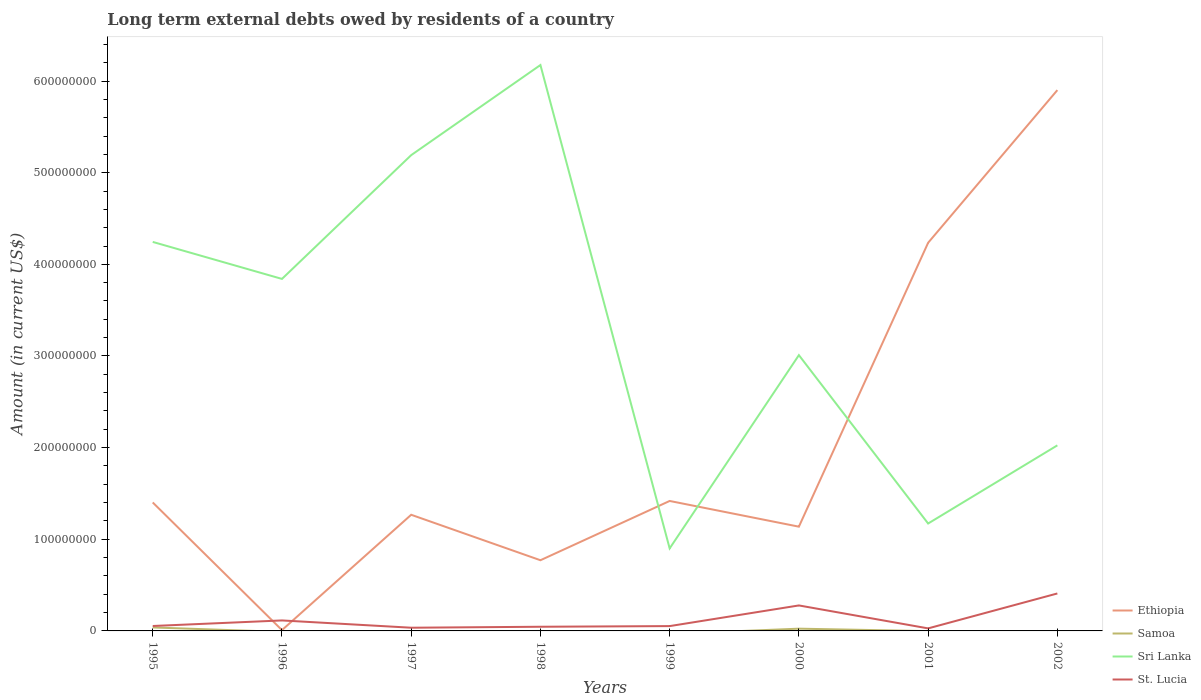Does the line corresponding to Ethiopia intersect with the line corresponding to St. Lucia?
Provide a succinct answer. Yes. Across all years, what is the maximum amount of long-term external debts owed by residents in Sri Lanka?
Provide a short and direct response. 9.00e+07. What is the total amount of long-term external debts owed by residents in St. Lucia in the graph?
Offer a very short reply. -3.56e+07. What is the difference between the highest and the second highest amount of long-term external debts owed by residents in St. Lucia?
Your response must be concise. 3.81e+07. Is the amount of long-term external debts owed by residents in Sri Lanka strictly greater than the amount of long-term external debts owed by residents in St. Lucia over the years?
Ensure brevity in your answer.  No. What is the difference between two consecutive major ticks on the Y-axis?
Offer a very short reply. 1.00e+08. Are the values on the major ticks of Y-axis written in scientific E-notation?
Give a very brief answer. No. Does the graph contain any zero values?
Offer a very short reply. Yes. Where does the legend appear in the graph?
Ensure brevity in your answer.  Bottom right. How many legend labels are there?
Your response must be concise. 4. How are the legend labels stacked?
Give a very brief answer. Vertical. What is the title of the graph?
Provide a short and direct response. Long term external debts owed by residents of a country. Does "Marshall Islands" appear as one of the legend labels in the graph?
Keep it short and to the point. No. What is the label or title of the X-axis?
Ensure brevity in your answer.  Years. What is the Amount (in current US$) of Ethiopia in 1995?
Keep it short and to the point. 1.40e+08. What is the Amount (in current US$) of Samoa in 1995?
Offer a very short reply. 3.79e+06. What is the Amount (in current US$) in Sri Lanka in 1995?
Make the answer very short. 4.24e+08. What is the Amount (in current US$) of St. Lucia in 1995?
Provide a succinct answer. 5.36e+06. What is the Amount (in current US$) of Ethiopia in 1996?
Your answer should be compact. 8.89e+05. What is the Amount (in current US$) of Sri Lanka in 1996?
Provide a succinct answer. 3.84e+08. What is the Amount (in current US$) of St. Lucia in 1996?
Provide a succinct answer. 1.14e+07. What is the Amount (in current US$) in Ethiopia in 1997?
Ensure brevity in your answer.  1.27e+08. What is the Amount (in current US$) of Sri Lanka in 1997?
Ensure brevity in your answer.  5.19e+08. What is the Amount (in current US$) of St. Lucia in 1997?
Give a very brief answer. 3.50e+06. What is the Amount (in current US$) of Ethiopia in 1998?
Make the answer very short. 7.71e+07. What is the Amount (in current US$) of Sri Lanka in 1998?
Provide a short and direct response. 6.17e+08. What is the Amount (in current US$) of St. Lucia in 1998?
Ensure brevity in your answer.  4.56e+06. What is the Amount (in current US$) of Ethiopia in 1999?
Make the answer very short. 1.42e+08. What is the Amount (in current US$) of Sri Lanka in 1999?
Provide a short and direct response. 9.00e+07. What is the Amount (in current US$) of St. Lucia in 1999?
Ensure brevity in your answer.  5.26e+06. What is the Amount (in current US$) in Ethiopia in 2000?
Give a very brief answer. 1.14e+08. What is the Amount (in current US$) of Samoa in 2000?
Keep it short and to the point. 2.46e+06. What is the Amount (in current US$) of Sri Lanka in 2000?
Your answer should be compact. 3.01e+08. What is the Amount (in current US$) of St. Lucia in 2000?
Make the answer very short. 2.78e+07. What is the Amount (in current US$) of Ethiopia in 2001?
Provide a succinct answer. 4.24e+08. What is the Amount (in current US$) in Samoa in 2001?
Provide a succinct answer. 0. What is the Amount (in current US$) in Sri Lanka in 2001?
Your answer should be compact. 1.17e+08. What is the Amount (in current US$) of St. Lucia in 2001?
Keep it short and to the point. 2.76e+06. What is the Amount (in current US$) in Ethiopia in 2002?
Provide a succinct answer. 5.90e+08. What is the Amount (in current US$) in Sri Lanka in 2002?
Make the answer very short. 2.02e+08. What is the Amount (in current US$) of St. Lucia in 2002?
Give a very brief answer. 4.09e+07. Across all years, what is the maximum Amount (in current US$) in Ethiopia?
Keep it short and to the point. 5.90e+08. Across all years, what is the maximum Amount (in current US$) of Samoa?
Your response must be concise. 3.79e+06. Across all years, what is the maximum Amount (in current US$) of Sri Lanka?
Make the answer very short. 6.17e+08. Across all years, what is the maximum Amount (in current US$) of St. Lucia?
Offer a terse response. 4.09e+07. Across all years, what is the minimum Amount (in current US$) in Ethiopia?
Ensure brevity in your answer.  8.89e+05. Across all years, what is the minimum Amount (in current US$) of Samoa?
Provide a succinct answer. 0. Across all years, what is the minimum Amount (in current US$) in Sri Lanka?
Your answer should be very brief. 9.00e+07. Across all years, what is the minimum Amount (in current US$) of St. Lucia?
Your answer should be compact. 2.76e+06. What is the total Amount (in current US$) in Ethiopia in the graph?
Offer a very short reply. 1.61e+09. What is the total Amount (in current US$) of Samoa in the graph?
Provide a succinct answer. 6.24e+06. What is the total Amount (in current US$) of Sri Lanka in the graph?
Your answer should be very brief. 2.66e+09. What is the total Amount (in current US$) of St. Lucia in the graph?
Make the answer very short. 1.02e+08. What is the difference between the Amount (in current US$) of Ethiopia in 1995 and that in 1996?
Give a very brief answer. 1.39e+08. What is the difference between the Amount (in current US$) in Sri Lanka in 1995 and that in 1996?
Your answer should be very brief. 4.04e+07. What is the difference between the Amount (in current US$) of St. Lucia in 1995 and that in 1996?
Your response must be concise. -6.07e+06. What is the difference between the Amount (in current US$) in Ethiopia in 1995 and that in 1997?
Offer a very short reply. 1.34e+07. What is the difference between the Amount (in current US$) in Sri Lanka in 1995 and that in 1997?
Give a very brief answer. -9.47e+07. What is the difference between the Amount (in current US$) of St. Lucia in 1995 and that in 1997?
Give a very brief answer. 1.87e+06. What is the difference between the Amount (in current US$) of Ethiopia in 1995 and that in 1998?
Offer a very short reply. 6.30e+07. What is the difference between the Amount (in current US$) in Sri Lanka in 1995 and that in 1998?
Your answer should be compact. -1.93e+08. What is the difference between the Amount (in current US$) of St. Lucia in 1995 and that in 1998?
Give a very brief answer. 8.06e+05. What is the difference between the Amount (in current US$) in Ethiopia in 1995 and that in 1999?
Ensure brevity in your answer.  -1.63e+06. What is the difference between the Amount (in current US$) in Sri Lanka in 1995 and that in 1999?
Provide a short and direct response. 3.34e+08. What is the difference between the Amount (in current US$) of Ethiopia in 1995 and that in 2000?
Provide a short and direct response. 2.64e+07. What is the difference between the Amount (in current US$) in Samoa in 1995 and that in 2000?
Give a very brief answer. 1.33e+06. What is the difference between the Amount (in current US$) of Sri Lanka in 1995 and that in 2000?
Your answer should be very brief. 1.24e+08. What is the difference between the Amount (in current US$) of St. Lucia in 1995 and that in 2000?
Keep it short and to the point. -2.24e+07. What is the difference between the Amount (in current US$) in Ethiopia in 1995 and that in 2001?
Ensure brevity in your answer.  -2.83e+08. What is the difference between the Amount (in current US$) of Sri Lanka in 1995 and that in 2001?
Your answer should be compact. 3.07e+08. What is the difference between the Amount (in current US$) of St. Lucia in 1995 and that in 2001?
Ensure brevity in your answer.  2.60e+06. What is the difference between the Amount (in current US$) of Ethiopia in 1995 and that in 2002?
Ensure brevity in your answer.  -4.50e+08. What is the difference between the Amount (in current US$) of Sri Lanka in 1995 and that in 2002?
Your answer should be compact. 2.22e+08. What is the difference between the Amount (in current US$) in St. Lucia in 1995 and that in 2002?
Provide a short and direct response. -3.55e+07. What is the difference between the Amount (in current US$) in Ethiopia in 1996 and that in 1997?
Make the answer very short. -1.26e+08. What is the difference between the Amount (in current US$) of Sri Lanka in 1996 and that in 1997?
Give a very brief answer. -1.35e+08. What is the difference between the Amount (in current US$) in St. Lucia in 1996 and that in 1997?
Your answer should be very brief. 7.94e+06. What is the difference between the Amount (in current US$) in Ethiopia in 1996 and that in 1998?
Your answer should be very brief. -7.62e+07. What is the difference between the Amount (in current US$) of Sri Lanka in 1996 and that in 1998?
Provide a succinct answer. -2.33e+08. What is the difference between the Amount (in current US$) of St. Lucia in 1996 and that in 1998?
Provide a succinct answer. 6.88e+06. What is the difference between the Amount (in current US$) in Ethiopia in 1996 and that in 1999?
Provide a succinct answer. -1.41e+08. What is the difference between the Amount (in current US$) in Sri Lanka in 1996 and that in 1999?
Your answer should be compact. 2.94e+08. What is the difference between the Amount (in current US$) of St. Lucia in 1996 and that in 1999?
Ensure brevity in your answer.  6.17e+06. What is the difference between the Amount (in current US$) in Ethiopia in 1996 and that in 2000?
Provide a short and direct response. -1.13e+08. What is the difference between the Amount (in current US$) of Sri Lanka in 1996 and that in 2000?
Your answer should be very brief. 8.32e+07. What is the difference between the Amount (in current US$) in St. Lucia in 1996 and that in 2000?
Provide a succinct answer. -1.64e+07. What is the difference between the Amount (in current US$) of Ethiopia in 1996 and that in 2001?
Provide a succinct answer. -4.23e+08. What is the difference between the Amount (in current US$) in Sri Lanka in 1996 and that in 2001?
Your answer should be compact. 2.67e+08. What is the difference between the Amount (in current US$) of St. Lucia in 1996 and that in 2001?
Offer a terse response. 8.67e+06. What is the difference between the Amount (in current US$) of Ethiopia in 1996 and that in 2002?
Your response must be concise. -5.89e+08. What is the difference between the Amount (in current US$) of Sri Lanka in 1996 and that in 2002?
Ensure brevity in your answer.  1.82e+08. What is the difference between the Amount (in current US$) of St. Lucia in 1996 and that in 2002?
Keep it short and to the point. -2.94e+07. What is the difference between the Amount (in current US$) in Ethiopia in 1997 and that in 1998?
Make the answer very short. 4.96e+07. What is the difference between the Amount (in current US$) of Sri Lanka in 1997 and that in 1998?
Make the answer very short. -9.83e+07. What is the difference between the Amount (in current US$) in St. Lucia in 1997 and that in 1998?
Make the answer very short. -1.06e+06. What is the difference between the Amount (in current US$) of Ethiopia in 1997 and that in 1999?
Ensure brevity in your answer.  -1.51e+07. What is the difference between the Amount (in current US$) of Sri Lanka in 1997 and that in 1999?
Your answer should be compact. 4.29e+08. What is the difference between the Amount (in current US$) of St. Lucia in 1997 and that in 1999?
Offer a very short reply. -1.77e+06. What is the difference between the Amount (in current US$) in Ethiopia in 1997 and that in 2000?
Offer a very short reply. 1.30e+07. What is the difference between the Amount (in current US$) of Sri Lanka in 1997 and that in 2000?
Your answer should be very brief. 2.18e+08. What is the difference between the Amount (in current US$) in St. Lucia in 1997 and that in 2000?
Your answer should be compact. -2.43e+07. What is the difference between the Amount (in current US$) of Ethiopia in 1997 and that in 2001?
Your answer should be very brief. -2.97e+08. What is the difference between the Amount (in current US$) of Sri Lanka in 1997 and that in 2001?
Your answer should be compact. 4.02e+08. What is the difference between the Amount (in current US$) of St. Lucia in 1997 and that in 2001?
Provide a short and direct response. 7.31e+05. What is the difference between the Amount (in current US$) of Ethiopia in 1997 and that in 2002?
Give a very brief answer. -4.63e+08. What is the difference between the Amount (in current US$) of Sri Lanka in 1997 and that in 2002?
Provide a succinct answer. 3.17e+08. What is the difference between the Amount (in current US$) in St. Lucia in 1997 and that in 2002?
Provide a short and direct response. -3.74e+07. What is the difference between the Amount (in current US$) in Ethiopia in 1998 and that in 1999?
Provide a short and direct response. -6.47e+07. What is the difference between the Amount (in current US$) in Sri Lanka in 1998 and that in 1999?
Make the answer very short. 5.27e+08. What is the difference between the Amount (in current US$) in St. Lucia in 1998 and that in 1999?
Provide a succinct answer. -7.06e+05. What is the difference between the Amount (in current US$) in Ethiopia in 1998 and that in 2000?
Make the answer very short. -3.66e+07. What is the difference between the Amount (in current US$) of Sri Lanka in 1998 and that in 2000?
Offer a very short reply. 3.17e+08. What is the difference between the Amount (in current US$) of St. Lucia in 1998 and that in 2000?
Provide a succinct answer. -2.33e+07. What is the difference between the Amount (in current US$) in Ethiopia in 1998 and that in 2001?
Provide a succinct answer. -3.46e+08. What is the difference between the Amount (in current US$) in Sri Lanka in 1998 and that in 2001?
Ensure brevity in your answer.  5.00e+08. What is the difference between the Amount (in current US$) of St. Lucia in 1998 and that in 2001?
Ensure brevity in your answer.  1.79e+06. What is the difference between the Amount (in current US$) of Ethiopia in 1998 and that in 2002?
Ensure brevity in your answer.  -5.13e+08. What is the difference between the Amount (in current US$) in Sri Lanka in 1998 and that in 2002?
Offer a terse response. 4.15e+08. What is the difference between the Amount (in current US$) in St. Lucia in 1998 and that in 2002?
Give a very brief answer. -3.63e+07. What is the difference between the Amount (in current US$) of Ethiopia in 1999 and that in 2000?
Give a very brief answer. 2.81e+07. What is the difference between the Amount (in current US$) in Sri Lanka in 1999 and that in 2000?
Keep it short and to the point. -2.11e+08. What is the difference between the Amount (in current US$) of St. Lucia in 1999 and that in 2000?
Your response must be concise. -2.25e+07. What is the difference between the Amount (in current US$) of Ethiopia in 1999 and that in 2001?
Provide a short and direct response. -2.82e+08. What is the difference between the Amount (in current US$) of Sri Lanka in 1999 and that in 2001?
Give a very brief answer. -2.72e+07. What is the difference between the Amount (in current US$) in St. Lucia in 1999 and that in 2001?
Make the answer very short. 2.50e+06. What is the difference between the Amount (in current US$) of Ethiopia in 1999 and that in 2002?
Provide a succinct answer. -4.48e+08. What is the difference between the Amount (in current US$) in Sri Lanka in 1999 and that in 2002?
Your answer should be compact. -1.12e+08. What is the difference between the Amount (in current US$) in St. Lucia in 1999 and that in 2002?
Offer a terse response. -3.56e+07. What is the difference between the Amount (in current US$) in Ethiopia in 2000 and that in 2001?
Your answer should be very brief. -3.10e+08. What is the difference between the Amount (in current US$) in Sri Lanka in 2000 and that in 2001?
Offer a very short reply. 1.84e+08. What is the difference between the Amount (in current US$) of St. Lucia in 2000 and that in 2001?
Your answer should be very brief. 2.50e+07. What is the difference between the Amount (in current US$) of Ethiopia in 2000 and that in 2002?
Your answer should be very brief. -4.76e+08. What is the difference between the Amount (in current US$) in Sri Lanka in 2000 and that in 2002?
Provide a short and direct response. 9.84e+07. What is the difference between the Amount (in current US$) of St. Lucia in 2000 and that in 2002?
Provide a succinct answer. -1.31e+07. What is the difference between the Amount (in current US$) in Ethiopia in 2001 and that in 2002?
Give a very brief answer. -1.67e+08. What is the difference between the Amount (in current US$) of Sri Lanka in 2001 and that in 2002?
Your response must be concise. -8.53e+07. What is the difference between the Amount (in current US$) in St. Lucia in 2001 and that in 2002?
Offer a terse response. -3.81e+07. What is the difference between the Amount (in current US$) of Ethiopia in 1995 and the Amount (in current US$) of Sri Lanka in 1996?
Provide a succinct answer. -2.44e+08. What is the difference between the Amount (in current US$) in Ethiopia in 1995 and the Amount (in current US$) in St. Lucia in 1996?
Your answer should be compact. 1.29e+08. What is the difference between the Amount (in current US$) in Samoa in 1995 and the Amount (in current US$) in Sri Lanka in 1996?
Provide a short and direct response. -3.80e+08. What is the difference between the Amount (in current US$) in Samoa in 1995 and the Amount (in current US$) in St. Lucia in 1996?
Offer a very short reply. -7.65e+06. What is the difference between the Amount (in current US$) of Sri Lanka in 1995 and the Amount (in current US$) of St. Lucia in 1996?
Your answer should be compact. 4.13e+08. What is the difference between the Amount (in current US$) of Ethiopia in 1995 and the Amount (in current US$) of Sri Lanka in 1997?
Offer a terse response. -3.79e+08. What is the difference between the Amount (in current US$) in Ethiopia in 1995 and the Amount (in current US$) in St. Lucia in 1997?
Provide a short and direct response. 1.37e+08. What is the difference between the Amount (in current US$) of Samoa in 1995 and the Amount (in current US$) of Sri Lanka in 1997?
Provide a succinct answer. -5.15e+08. What is the difference between the Amount (in current US$) of Samoa in 1995 and the Amount (in current US$) of St. Lucia in 1997?
Your response must be concise. 2.91e+05. What is the difference between the Amount (in current US$) of Sri Lanka in 1995 and the Amount (in current US$) of St. Lucia in 1997?
Your answer should be compact. 4.21e+08. What is the difference between the Amount (in current US$) in Ethiopia in 1995 and the Amount (in current US$) in Sri Lanka in 1998?
Keep it short and to the point. -4.77e+08. What is the difference between the Amount (in current US$) of Ethiopia in 1995 and the Amount (in current US$) of St. Lucia in 1998?
Keep it short and to the point. 1.36e+08. What is the difference between the Amount (in current US$) in Samoa in 1995 and the Amount (in current US$) in Sri Lanka in 1998?
Give a very brief answer. -6.14e+08. What is the difference between the Amount (in current US$) of Samoa in 1995 and the Amount (in current US$) of St. Lucia in 1998?
Ensure brevity in your answer.  -7.70e+05. What is the difference between the Amount (in current US$) in Sri Lanka in 1995 and the Amount (in current US$) in St. Lucia in 1998?
Your answer should be very brief. 4.20e+08. What is the difference between the Amount (in current US$) in Ethiopia in 1995 and the Amount (in current US$) in Sri Lanka in 1999?
Offer a very short reply. 5.01e+07. What is the difference between the Amount (in current US$) of Ethiopia in 1995 and the Amount (in current US$) of St. Lucia in 1999?
Provide a succinct answer. 1.35e+08. What is the difference between the Amount (in current US$) in Samoa in 1995 and the Amount (in current US$) in Sri Lanka in 1999?
Ensure brevity in your answer.  -8.62e+07. What is the difference between the Amount (in current US$) of Samoa in 1995 and the Amount (in current US$) of St. Lucia in 1999?
Provide a short and direct response. -1.48e+06. What is the difference between the Amount (in current US$) of Sri Lanka in 1995 and the Amount (in current US$) of St. Lucia in 1999?
Offer a terse response. 4.19e+08. What is the difference between the Amount (in current US$) in Ethiopia in 1995 and the Amount (in current US$) in Samoa in 2000?
Your response must be concise. 1.38e+08. What is the difference between the Amount (in current US$) in Ethiopia in 1995 and the Amount (in current US$) in Sri Lanka in 2000?
Provide a short and direct response. -1.61e+08. What is the difference between the Amount (in current US$) in Ethiopia in 1995 and the Amount (in current US$) in St. Lucia in 2000?
Your answer should be very brief. 1.12e+08. What is the difference between the Amount (in current US$) of Samoa in 1995 and the Amount (in current US$) of Sri Lanka in 2000?
Your answer should be very brief. -2.97e+08. What is the difference between the Amount (in current US$) of Samoa in 1995 and the Amount (in current US$) of St. Lucia in 2000?
Ensure brevity in your answer.  -2.40e+07. What is the difference between the Amount (in current US$) of Sri Lanka in 1995 and the Amount (in current US$) of St. Lucia in 2000?
Your answer should be compact. 3.97e+08. What is the difference between the Amount (in current US$) of Ethiopia in 1995 and the Amount (in current US$) of Sri Lanka in 2001?
Your answer should be compact. 2.30e+07. What is the difference between the Amount (in current US$) in Ethiopia in 1995 and the Amount (in current US$) in St. Lucia in 2001?
Make the answer very short. 1.37e+08. What is the difference between the Amount (in current US$) in Samoa in 1995 and the Amount (in current US$) in Sri Lanka in 2001?
Provide a short and direct response. -1.13e+08. What is the difference between the Amount (in current US$) of Samoa in 1995 and the Amount (in current US$) of St. Lucia in 2001?
Offer a very short reply. 1.02e+06. What is the difference between the Amount (in current US$) of Sri Lanka in 1995 and the Amount (in current US$) of St. Lucia in 2001?
Offer a very short reply. 4.22e+08. What is the difference between the Amount (in current US$) of Ethiopia in 1995 and the Amount (in current US$) of Sri Lanka in 2002?
Keep it short and to the point. -6.23e+07. What is the difference between the Amount (in current US$) in Ethiopia in 1995 and the Amount (in current US$) in St. Lucia in 2002?
Give a very brief answer. 9.93e+07. What is the difference between the Amount (in current US$) in Samoa in 1995 and the Amount (in current US$) in Sri Lanka in 2002?
Give a very brief answer. -1.99e+08. What is the difference between the Amount (in current US$) in Samoa in 1995 and the Amount (in current US$) in St. Lucia in 2002?
Provide a short and direct response. -3.71e+07. What is the difference between the Amount (in current US$) in Sri Lanka in 1995 and the Amount (in current US$) in St. Lucia in 2002?
Your answer should be compact. 3.84e+08. What is the difference between the Amount (in current US$) in Ethiopia in 1996 and the Amount (in current US$) in Sri Lanka in 1997?
Your answer should be very brief. -5.18e+08. What is the difference between the Amount (in current US$) of Ethiopia in 1996 and the Amount (in current US$) of St. Lucia in 1997?
Provide a short and direct response. -2.61e+06. What is the difference between the Amount (in current US$) in Sri Lanka in 1996 and the Amount (in current US$) in St. Lucia in 1997?
Offer a terse response. 3.81e+08. What is the difference between the Amount (in current US$) of Ethiopia in 1996 and the Amount (in current US$) of Sri Lanka in 1998?
Offer a terse response. -6.17e+08. What is the difference between the Amount (in current US$) of Ethiopia in 1996 and the Amount (in current US$) of St. Lucia in 1998?
Your response must be concise. -3.67e+06. What is the difference between the Amount (in current US$) in Sri Lanka in 1996 and the Amount (in current US$) in St. Lucia in 1998?
Make the answer very short. 3.80e+08. What is the difference between the Amount (in current US$) of Ethiopia in 1996 and the Amount (in current US$) of Sri Lanka in 1999?
Provide a short and direct response. -8.91e+07. What is the difference between the Amount (in current US$) of Ethiopia in 1996 and the Amount (in current US$) of St. Lucia in 1999?
Your answer should be very brief. -4.37e+06. What is the difference between the Amount (in current US$) of Sri Lanka in 1996 and the Amount (in current US$) of St. Lucia in 1999?
Keep it short and to the point. 3.79e+08. What is the difference between the Amount (in current US$) of Ethiopia in 1996 and the Amount (in current US$) of Samoa in 2000?
Your answer should be very brief. -1.57e+06. What is the difference between the Amount (in current US$) in Ethiopia in 1996 and the Amount (in current US$) in Sri Lanka in 2000?
Offer a very short reply. -3.00e+08. What is the difference between the Amount (in current US$) of Ethiopia in 1996 and the Amount (in current US$) of St. Lucia in 2000?
Keep it short and to the point. -2.69e+07. What is the difference between the Amount (in current US$) in Sri Lanka in 1996 and the Amount (in current US$) in St. Lucia in 2000?
Keep it short and to the point. 3.56e+08. What is the difference between the Amount (in current US$) in Ethiopia in 1996 and the Amount (in current US$) in Sri Lanka in 2001?
Give a very brief answer. -1.16e+08. What is the difference between the Amount (in current US$) of Ethiopia in 1996 and the Amount (in current US$) of St. Lucia in 2001?
Provide a succinct answer. -1.88e+06. What is the difference between the Amount (in current US$) of Sri Lanka in 1996 and the Amount (in current US$) of St. Lucia in 2001?
Your response must be concise. 3.81e+08. What is the difference between the Amount (in current US$) in Ethiopia in 1996 and the Amount (in current US$) in Sri Lanka in 2002?
Your response must be concise. -2.02e+08. What is the difference between the Amount (in current US$) of Ethiopia in 1996 and the Amount (in current US$) of St. Lucia in 2002?
Your response must be concise. -4.00e+07. What is the difference between the Amount (in current US$) of Sri Lanka in 1996 and the Amount (in current US$) of St. Lucia in 2002?
Provide a short and direct response. 3.43e+08. What is the difference between the Amount (in current US$) in Ethiopia in 1997 and the Amount (in current US$) in Sri Lanka in 1998?
Provide a succinct answer. -4.91e+08. What is the difference between the Amount (in current US$) in Ethiopia in 1997 and the Amount (in current US$) in St. Lucia in 1998?
Offer a very short reply. 1.22e+08. What is the difference between the Amount (in current US$) of Sri Lanka in 1997 and the Amount (in current US$) of St. Lucia in 1998?
Provide a short and direct response. 5.15e+08. What is the difference between the Amount (in current US$) in Ethiopia in 1997 and the Amount (in current US$) in Sri Lanka in 1999?
Make the answer very short. 3.67e+07. What is the difference between the Amount (in current US$) in Ethiopia in 1997 and the Amount (in current US$) in St. Lucia in 1999?
Give a very brief answer. 1.21e+08. What is the difference between the Amount (in current US$) of Sri Lanka in 1997 and the Amount (in current US$) of St. Lucia in 1999?
Provide a succinct answer. 5.14e+08. What is the difference between the Amount (in current US$) in Ethiopia in 1997 and the Amount (in current US$) in Samoa in 2000?
Provide a succinct answer. 1.24e+08. What is the difference between the Amount (in current US$) in Ethiopia in 1997 and the Amount (in current US$) in Sri Lanka in 2000?
Your answer should be very brief. -1.74e+08. What is the difference between the Amount (in current US$) in Ethiopia in 1997 and the Amount (in current US$) in St. Lucia in 2000?
Provide a succinct answer. 9.89e+07. What is the difference between the Amount (in current US$) of Sri Lanka in 1997 and the Amount (in current US$) of St. Lucia in 2000?
Make the answer very short. 4.91e+08. What is the difference between the Amount (in current US$) in Ethiopia in 1997 and the Amount (in current US$) in Sri Lanka in 2001?
Keep it short and to the point. 9.54e+06. What is the difference between the Amount (in current US$) in Ethiopia in 1997 and the Amount (in current US$) in St. Lucia in 2001?
Offer a very short reply. 1.24e+08. What is the difference between the Amount (in current US$) of Sri Lanka in 1997 and the Amount (in current US$) of St. Lucia in 2001?
Your response must be concise. 5.16e+08. What is the difference between the Amount (in current US$) of Ethiopia in 1997 and the Amount (in current US$) of Sri Lanka in 2002?
Make the answer very short. -7.57e+07. What is the difference between the Amount (in current US$) of Ethiopia in 1997 and the Amount (in current US$) of St. Lucia in 2002?
Provide a succinct answer. 8.59e+07. What is the difference between the Amount (in current US$) of Sri Lanka in 1997 and the Amount (in current US$) of St. Lucia in 2002?
Offer a terse response. 4.78e+08. What is the difference between the Amount (in current US$) of Ethiopia in 1998 and the Amount (in current US$) of Sri Lanka in 1999?
Give a very brief answer. -1.29e+07. What is the difference between the Amount (in current US$) of Ethiopia in 1998 and the Amount (in current US$) of St. Lucia in 1999?
Offer a very short reply. 7.19e+07. What is the difference between the Amount (in current US$) in Sri Lanka in 1998 and the Amount (in current US$) in St. Lucia in 1999?
Keep it short and to the point. 6.12e+08. What is the difference between the Amount (in current US$) of Ethiopia in 1998 and the Amount (in current US$) of Samoa in 2000?
Your response must be concise. 7.47e+07. What is the difference between the Amount (in current US$) in Ethiopia in 1998 and the Amount (in current US$) in Sri Lanka in 2000?
Keep it short and to the point. -2.24e+08. What is the difference between the Amount (in current US$) in Ethiopia in 1998 and the Amount (in current US$) in St. Lucia in 2000?
Your response must be concise. 4.93e+07. What is the difference between the Amount (in current US$) in Sri Lanka in 1998 and the Amount (in current US$) in St. Lucia in 2000?
Ensure brevity in your answer.  5.90e+08. What is the difference between the Amount (in current US$) of Ethiopia in 1998 and the Amount (in current US$) of Sri Lanka in 2001?
Provide a short and direct response. -4.01e+07. What is the difference between the Amount (in current US$) of Ethiopia in 1998 and the Amount (in current US$) of St. Lucia in 2001?
Ensure brevity in your answer.  7.44e+07. What is the difference between the Amount (in current US$) of Sri Lanka in 1998 and the Amount (in current US$) of St. Lucia in 2001?
Your response must be concise. 6.15e+08. What is the difference between the Amount (in current US$) of Ethiopia in 1998 and the Amount (in current US$) of Sri Lanka in 2002?
Ensure brevity in your answer.  -1.25e+08. What is the difference between the Amount (in current US$) of Ethiopia in 1998 and the Amount (in current US$) of St. Lucia in 2002?
Ensure brevity in your answer.  3.63e+07. What is the difference between the Amount (in current US$) of Sri Lanka in 1998 and the Amount (in current US$) of St. Lucia in 2002?
Offer a terse response. 5.77e+08. What is the difference between the Amount (in current US$) in Ethiopia in 1999 and the Amount (in current US$) in Samoa in 2000?
Provide a short and direct response. 1.39e+08. What is the difference between the Amount (in current US$) in Ethiopia in 1999 and the Amount (in current US$) in Sri Lanka in 2000?
Offer a very short reply. -1.59e+08. What is the difference between the Amount (in current US$) of Ethiopia in 1999 and the Amount (in current US$) of St. Lucia in 2000?
Keep it short and to the point. 1.14e+08. What is the difference between the Amount (in current US$) in Sri Lanka in 1999 and the Amount (in current US$) in St. Lucia in 2000?
Your answer should be very brief. 6.22e+07. What is the difference between the Amount (in current US$) of Ethiopia in 1999 and the Amount (in current US$) of Sri Lanka in 2001?
Make the answer very short. 2.46e+07. What is the difference between the Amount (in current US$) in Ethiopia in 1999 and the Amount (in current US$) in St. Lucia in 2001?
Your answer should be very brief. 1.39e+08. What is the difference between the Amount (in current US$) of Sri Lanka in 1999 and the Amount (in current US$) of St. Lucia in 2001?
Offer a terse response. 8.73e+07. What is the difference between the Amount (in current US$) in Ethiopia in 1999 and the Amount (in current US$) in Sri Lanka in 2002?
Your response must be concise. -6.07e+07. What is the difference between the Amount (in current US$) of Ethiopia in 1999 and the Amount (in current US$) of St. Lucia in 2002?
Provide a short and direct response. 1.01e+08. What is the difference between the Amount (in current US$) of Sri Lanka in 1999 and the Amount (in current US$) of St. Lucia in 2002?
Give a very brief answer. 4.92e+07. What is the difference between the Amount (in current US$) in Ethiopia in 2000 and the Amount (in current US$) in Sri Lanka in 2001?
Ensure brevity in your answer.  -3.44e+06. What is the difference between the Amount (in current US$) in Ethiopia in 2000 and the Amount (in current US$) in St. Lucia in 2001?
Your answer should be compact. 1.11e+08. What is the difference between the Amount (in current US$) of Samoa in 2000 and the Amount (in current US$) of Sri Lanka in 2001?
Your answer should be very brief. -1.15e+08. What is the difference between the Amount (in current US$) of Samoa in 2000 and the Amount (in current US$) of St. Lucia in 2001?
Offer a terse response. -3.09e+05. What is the difference between the Amount (in current US$) in Sri Lanka in 2000 and the Amount (in current US$) in St. Lucia in 2001?
Make the answer very short. 2.98e+08. What is the difference between the Amount (in current US$) of Ethiopia in 2000 and the Amount (in current US$) of Sri Lanka in 2002?
Provide a succinct answer. -8.87e+07. What is the difference between the Amount (in current US$) of Ethiopia in 2000 and the Amount (in current US$) of St. Lucia in 2002?
Keep it short and to the point. 7.29e+07. What is the difference between the Amount (in current US$) of Samoa in 2000 and the Amount (in current US$) of Sri Lanka in 2002?
Keep it short and to the point. -2.00e+08. What is the difference between the Amount (in current US$) of Samoa in 2000 and the Amount (in current US$) of St. Lucia in 2002?
Offer a terse response. -3.84e+07. What is the difference between the Amount (in current US$) in Sri Lanka in 2000 and the Amount (in current US$) in St. Lucia in 2002?
Keep it short and to the point. 2.60e+08. What is the difference between the Amount (in current US$) in Ethiopia in 2001 and the Amount (in current US$) in Sri Lanka in 2002?
Give a very brief answer. 2.21e+08. What is the difference between the Amount (in current US$) of Ethiopia in 2001 and the Amount (in current US$) of St. Lucia in 2002?
Offer a very short reply. 3.83e+08. What is the difference between the Amount (in current US$) of Sri Lanka in 2001 and the Amount (in current US$) of St. Lucia in 2002?
Ensure brevity in your answer.  7.63e+07. What is the average Amount (in current US$) in Ethiopia per year?
Provide a short and direct response. 2.02e+08. What is the average Amount (in current US$) of Samoa per year?
Offer a very short reply. 7.80e+05. What is the average Amount (in current US$) in Sri Lanka per year?
Make the answer very short. 3.32e+08. What is the average Amount (in current US$) in St. Lucia per year?
Offer a terse response. 1.27e+07. In the year 1995, what is the difference between the Amount (in current US$) in Ethiopia and Amount (in current US$) in Samoa?
Ensure brevity in your answer.  1.36e+08. In the year 1995, what is the difference between the Amount (in current US$) in Ethiopia and Amount (in current US$) in Sri Lanka?
Your answer should be very brief. -2.84e+08. In the year 1995, what is the difference between the Amount (in current US$) of Ethiopia and Amount (in current US$) of St. Lucia?
Ensure brevity in your answer.  1.35e+08. In the year 1995, what is the difference between the Amount (in current US$) of Samoa and Amount (in current US$) of Sri Lanka?
Ensure brevity in your answer.  -4.21e+08. In the year 1995, what is the difference between the Amount (in current US$) in Samoa and Amount (in current US$) in St. Lucia?
Make the answer very short. -1.58e+06. In the year 1995, what is the difference between the Amount (in current US$) in Sri Lanka and Amount (in current US$) in St. Lucia?
Make the answer very short. 4.19e+08. In the year 1996, what is the difference between the Amount (in current US$) of Ethiopia and Amount (in current US$) of Sri Lanka?
Offer a very short reply. -3.83e+08. In the year 1996, what is the difference between the Amount (in current US$) of Ethiopia and Amount (in current US$) of St. Lucia?
Keep it short and to the point. -1.05e+07. In the year 1996, what is the difference between the Amount (in current US$) in Sri Lanka and Amount (in current US$) in St. Lucia?
Keep it short and to the point. 3.73e+08. In the year 1997, what is the difference between the Amount (in current US$) of Ethiopia and Amount (in current US$) of Sri Lanka?
Make the answer very short. -3.92e+08. In the year 1997, what is the difference between the Amount (in current US$) in Ethiopia and Amount (in current US$) in St. Lucia?
Ensure brevity in your answer.  1.23e+08. In the year 1997, what is the difference between the Amount (in current US$) in Sri Lanka and Amount (in current US$) in St. Lucia?
Keep it short and to the point. 5.16e+08. In the year 1998, what is the difference between the Amount (in current US$) in Ethiopia and Amount (in current US$) in Sri Lanka?
Keep it short and to the point. -5.40e+08. In the year 1998, what is the difference between the Amount (in current US$) of Ethiopia and Amount (in current US$) of St. Lucia?
Make the answer very short. 7.26e+07. In the year 1998, what is the difference between the Amount (in current US$) of Sri Lanka and Amount (in current US$) of St. Lucia?
Offer a terse response. 6.13e+08. In the year 1999, what is the difference between the Amount (in current US$) of Ethiopia and Amount (in current US$) of Sri Lanka?
Make the answer very short. 5.18e+07. In the year 1999, what is the difference between the Amount (in current US$) in Ethiopia and Amount (in current US$) in St. Lucia?
Provide a short and direct response. 1.37e+08. In the year 1999, what is the difference between the Amount (in current US$) of Sri Lanka and Amount (in current US$) of St. Lucia?
Ensure brevity in your answer.  8.48e+07. In the year 2000, what is the difference between the Amount (in current US$) of Ethiopia and Amount (in current US$) of Samoa?
Provide a succinct answer. 1.11e+08. In the year 2000, what is the difference between the Amount (in current US$) of Ethiopia and Amount (in current US$) of Sri Lanka?
Your answer should be very brief. -1.87e+08. In the year 2000, what is the difference between the Amount (in current US$) in Ethiopia and Amount (in current US$) in St. Lucia?
Your response must be concise. 8.59e+07. In the year 2000, what is the difference between the Amount (in current US$) of Samoa and Amount (in current US$) of Sri Lanka?
Make the answer very short. -2.98e+08. In the year 2000, what is the difference between the Amount (in current US$) in Samoa and Amount (in current US$) in St. Lucia?
Your response must be concise. -2.54e+07. In the year 2000, what is the difference between the Amount (in current US$) of Sri Lanka and Amount (in current US$) of St. Lucia?
Your answer should be compact. 2.73e+08. In the year 2001, what is the difference between the Amount (in current US$) of Ethiopia and Amount (in current US$) of Sri Lanka?
Offer a terse response. 3.06e+08. In the year 2001, what is the difference between the Amount (in current US$) in Ethiopia and Amount (in current US$) in St. Lucia?
Make the answer very short. 4.21e+08. In the year 2001, what is the difference between the Amount (in current US$) in Sri Lanka and Amount (in current US$) in St. Lucia?
Make the answer very short. 1.14e+08. In the year 2002, what is the difference between the Amount (in current US$) in Ethiopia and Amount (in current US$) in Sri Lanka?
Make the answer very short. 3.88e+08. In the year 2002, what is the difference between the Amount (in current US$) in Ethiopia and Amount (in current US$) in St. Lucia?
Give a very brief answer. 5.49e+08. In the year 2002, what is the difference between the Amount (in current US$) of Sri Lanka and Amount (in current US$) of St. Lucia?
Give a very brief answer. 1.62e+08. What is the ratio of the Amount (in current US$) of Ethiopia in 1995 to that in 1996?
Give a very brief answer. 157.68. What is the ratio of the Amount (in current US$) in Sri Lanka in 1995 to that in 1996?
Your answer should be very brief. 1.11. What is the ratio of the Amount (in current US$) of St. Lucia in 1995 to that in 1996?
Provide a short and direct response. 0.47. What is the ratio of the Amount (in current US$) of Ethiopia in 1995 to that in 1997?
Your response must be concise. 1.11. What is the ratio of the Amount (in current US$) of Sri Lanka in 1995 to that in 1997?
Give a very brief answer. 0.82. What is the ratio of the Amount (in current US$) of St. Lucia in 1995 to that in 1997?
Provide a short and direct response. 1.53. What is the ratio of the Amount (in current US$) in Ethiopia in 1995 to that in 1998?
Provide a short and direct response. 1.82. What is the ratio of the Amount (in current US$) in Sri Lanka in 1995 to that in 1998?
Offer a very short reply. 0.69. What is the ratio of the Amount (in current US$) in St. Lucia in 1995 to that in 1998?
Make the answer very short. 1.18. What is the ratio of the Amount (in current US$) in Ethiopia in 1995 to that in 1999?
Offer a very short reply. 0.99. What is the ratio of the Amount (in current US$) in Sri Lanka in 1995 to that in 1999?
Keep it short and to the point. 4.71. What is the ratio of the Amount (in current US$) of St. Lucia in 1995 to that in 1999?
Offer a terse response. 1.02. What is the ratio of the Amount (in current US$) of Ethiopia in 1995 to that in 2000?
Your answer should be very brief. 1.23. What is the ratio of the Amount (in current US$) in Samoa in 1995 to that in 2000?
Your answer should be very brief. 1.54. What is the ratio of the Amount (in current US$) of Sri Lanka in 1995 to that in 2000?
Ensure brevity in your answer.  1.41. What is the ratio of the Amount (in current US$) in St. Lucia in 1995 to that in 2000?
Provide a short and direct response. 0.19. What is the ratio of the Amount (in current US$) in Ethiopia in 1995 to that in 2001?
Give a very brief answer. 0.33. What is the ratio of the Amount (in current US$) of Sri Lanka in 1995 to that in 2001?
Your answer should be compact. 3.62. What is the ratio of the Amount (in current US$) of St. Lucia in 1995 to that in 2001?
Give a very brief answer. 1.94. What is the ratio of the Amount (in current US$) of Ethiopia in 1995 to that in 2002?
Offer a terse response. 0.24. What is the ratio of the Amount (in current US$) of Sri Lanka in 1995 to that in 2002?
Offer a very short reply. 2.1. What is the ratio of the Amount (in current US$) of St. Lucia in 1995 to that in 2002?
Give a very brief answer. 0.13. What is the ratio of the Amount (in current US$) of Ethiopia in 1996 to that in 1997?
Make the answer very short. 0.01. What is the ratio of the Amount (in current US$) in Sri Lanka in 1996 to that in 1997?
Offer a very short reply. 0.74. What is the ratio of the Amount (in current US$) in St. Lucia in 1996 to that in 1997?
Keep it short and to the point. 3.27. What is the ratio of the Amount (in current US$) of Ethiopia in 1996 to that in 1998?
Give a very brief answer. 0.01. What is the ratio of the Amount (in current US$) of Sri Lanka in 1996 to that in 1998?
Ensure brevity in your answer.  0.62. What is the ratio of the Amount (in current US$) in St. Lucia in 1996 to that in 1998?
Your answer should be very brief. 2.51. What is the ratio of the Amount (in current US$) of Ethiopia in 1996 to that in 1999?
Provide a short and direct response. 0.01. What is the ratio of the Amount (in current US$) of Sri Lanka in 1996 to that in 1999?
Keep it short and to the point. 4.27. What is the ratio of the Amount (in current US$) in St. Lucia in 1996 to that in 1999?
Ensure brevity in your answer.  2.17. What is the ratio of the Amount (in current US$) of Ethiopia in 1996 to that in 2000?
Your answer should be very brief. 0.01. What is the ratio of the Amount (in current US$) of Sri Lanka in 1996 to that in 2000?
Your response must be concise. 1.28. What is the ratio of the Amount (in current US$) in St. Lucia in 1996 to that in 2000?
Make the answer very short. 0.41. What is the ratio of the Amount (in current US$) in Ethiopia in 1996 to that in 2001?
Provide a succinct answer. 0. What is the ratio of the Amount (in current US$) in Sri Lanka in 1996 to that in 2001?
Ensure brevity in your answer.  3.28. What is the ratio of the Amount (in current US$) in St. Lucia in 1996 to that in 2001?
Your answer should be very brief. 4.14. What is the ratio of the Amount (in current US$) in Ethiopia in 1996 to that in 2002?
Your response must be concise. 0. What is the ratio of the Amount (in current US$) of Sri Lanka in 1996 to that in 2002?
Your response must be concise. 1.9. What is the ratio of the Amount (in current US$) of St. Lucia in 1996 to that in 2002?
Your response must be concise. 0.28. What is the ratio of the Amount (in current US$) in Ethiopia in 1997 to that in 1998?
Ensure brevity in your answer.  1.64. What is the ratio of the Amount (in current US$) of Sri Lanka in 1997 to that in 1998?
Your answer should be very brief. 0.84. What is the ratio of the Amount (in current US$) of St. Lucia in 1997 to that in 1998?
Offer a terse response. 0.77. What is the ratio of the Amount (in current US$) of Ethiopia in 1997 to that in 1999?
Make the answer very short. 0.89. What is the ratio of the Amount (in current US$) in Sri Lanka in 1997 to that in 1999?
Your answer should be very brief. 5.77. What is the ratio of the Amount (in current US$) of St. Lucia in 1997 to that in 1999?
Your response must be concise. 0.66. What is the ratio of the Amount (in current US$) in Ethiopia in 1997 to that in 2000?
Your response must be concise. 1.11. What is the ratio of the Amount (in current US$) in Sri Lanka in 1997 to that in 2000?
Offer a terse response. 1.73. What is the ratio of the Amount (in current US$) in St. Lucia in 1997 to that in 2000?
Keep it short and to the point. 0.13. What is the ratio of the Amount (in current US$) in Ethiopia in 1997 to that in 2001?
Provide a succinct answer. 0.3. What is the ratio of the Amount (in current US$) in Sri Lanka in 1997 to that in 2001?
Provide a short and direct response. 4.43. What is the ratio of the Amount (in current US$) of St. Lucia in 1997 to that in 2001?
Give a very brief answer. 1.26. What is the ratio of the Amount (in current US$) in Ethiopia in 1997 to that in 2002?
Your answer should be compact. 0.21. What is the ratio of the Amount (in current US$) in Sri Lanka in 1997 to that in 2002?
Provide a succinct answer. 2.56. What is the ratio of the Amount (in current US$) of St. Lucia in 1997 to that in 2002?
Offer a very short reply. 0.09. What is the ratio of the Amount (in current US$) of Ethiopia in 1998 to that in 1999?
Make the answer very short. 0.54. What is the ratio of the Amount (in current US$) of Sri Lanka in 1998 to that in 1999?
Make the answer very short. 6.86. What is the ratio of the Amount (in current US$) in St. Lucia in 1998 to that in 1999?
Your response must be concise. 0.87. What is the ratio of the Amount (in current US$) of Ethiopia in 1998 to that in 2000?
Make the answer very short. 0.68. What is the ratio of the Amount (in current US$) in Sri Lanka in 1998 to that in 2000?
Ensure brevity in your answer.  2.05. What is the ratio of the Amount (in current US$) of St. Lucia in 1998 to that in 2000?
Provide a succinct answer. 0.16. What is the ratio of the Amount (in current US$) of Ethiopia in 1998 to that in 2001?
Your response must be concise. 0.18. What is the ratio of the Amount (in current US$) in Sri Lanka in 1998 to that in 2001?
Give a very brief answer. 5.27. What is the ratio of the Amount (in current US$) in St. Lucia in 1998 to that in 2001?
Give a very brief answer. 1.65. What is the ratio of the Amount (in current US$) in Ethiopia in 1998 to that in 2002?
Provide a succinct answer. 0.13. What is the ratio of the Amount (in current US$) in Sri Lanka in 1998 to that in 2002?
Provide a short and direct response. 3.05. What is the ratio of the Amount (in current US$) of St. Lucia in 1998 to that in 2002?
Offer a very short reply. 0.11. What is the ratio of the Amount (in current US$) of Ethiopia in 1999 to that in 2000?
Provide a succinct answer. 1.25. What is the ratio of the Amount (in current US$) in Sri Lanka in 1999 to that in 2000?
Your answer should be very brief. 0.3. What is the ratio of the Amount (in current US$) of St. Lucia in 1999 to that in 2000?
Give a very brief answer. 0.19. What is the ratio of the Amount (in current US$) in Ethiopia in 1999 to that in 2001?
Give a very brief answer. 0.33. What is the ratio of the Amount (in current US$) of Sri Lanka in 1999 to that in 2001?
Your response must be concise. 0.77. What is the ratio of the Amount (in current US$) of St. Lucia in 1999 to that in 2001?
Provide a short and direct response. 1.9. What is the ratio of the Amount (in current US$) of Ethiopia in 1999 to that in 2002?
Make the answer very short. 0.24. What is the ratio of the Amount (in current US$) in Sri Lanka in 1999 to that in 2002?
Your response must be concise. 0.44. What is the ratio of the Amount (in current US$) of St. Lucia in 1999 to that in 2002?
Give a very brief answer. 0.13. What is the ratio of the Amount (in current US$) in Ethiopia in 2000 to that in 2001?
Offer a very short reply. 0.27. What is the ratio of the Amount (in current US$) of Sri Lanka in 2000 to that in 2001?
Provide a succinct answer. 2.57. What is the ratio of the Amount (in current US$) of St. Lucia in 2000 to that in 2001?
Make the answer very short. 10.06. What is the ratio of the Amount (in current US$) of Ethiopia in 2000 to that in 2002?
Your response must be concise. 0.19. What is the ratio of the Amount (in current US$) of Sri Lanka in 2000 to that in 2002?
Provide a succinct answer. 1.49. What is the ratio of the Amount (in current US$) of St. Lucia in 2000 to that in 2002?
Give a very brief answer. 0.68. What is the ratio of the Amount (in current US$) of Ethiopia in 2001 to that in 2002?
Offer a very short reply. 0.72. What is the ratio of the Amount (in current US$) in Sri Lanka in 2001 to that in 2002?
Make the answer very short. 0.58. What is the ratio of the Amount (in current US$) of St. Lucia in 2001 to that in 2002?
Give a very brief answer. 0.07. What is the difference between the highest and the second highest Amount (in current US$) in Ethiopia?
Make the answer very short. 1.67e+08. What is the difference between the highest and the second highest Amount (in current US$) of Sri Lanka?
Offer a terse response. 9.83e+07. What is the difference between the highest and the second highest Amount (in current US$) in St. Lucia?
Give a very brief answer. 1.31e+07. What is the difference between the highest and the lowest Amount (in current US$) of Ethiopia?
Offer a terse response. 5.89e+08. What is the difference between the highest and the lowest Amount (in current US$) of Samoa?
Offer a very short reply. 3.79e+06. What is the difference between the highest and the lowest Amount (in current US$) of Sri Lanka?
Keep it short and to the point. 5.27e+08. What is the difference between the highest and the lowest Amount (in current US$) of St. Lucia?
Offer a terse response. 3.81e+07. 